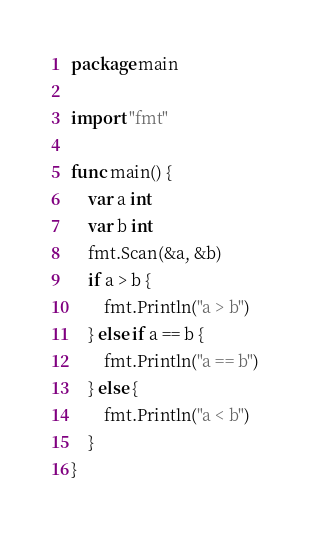Convert code to text. <code><loc_0><loc_0><loc_500><loc_500><_Go_>package main

import "fmt"

func main() {
	var a int
	var b int
	fmt.Scan(&a, &b)
	if a > b {
		fmt.Println("a > b")
	} else if a == b {
		fmt.Println("a == b")
	} else {
		fmt.Println("a < b")
	}
}
</code> 